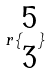Convert formula to latex. <formula><loc_0><loc_0><loc_500><loc_500>r \{ \begin{matrix} 5 \\ 3 \end{matrix} \}</formula> 